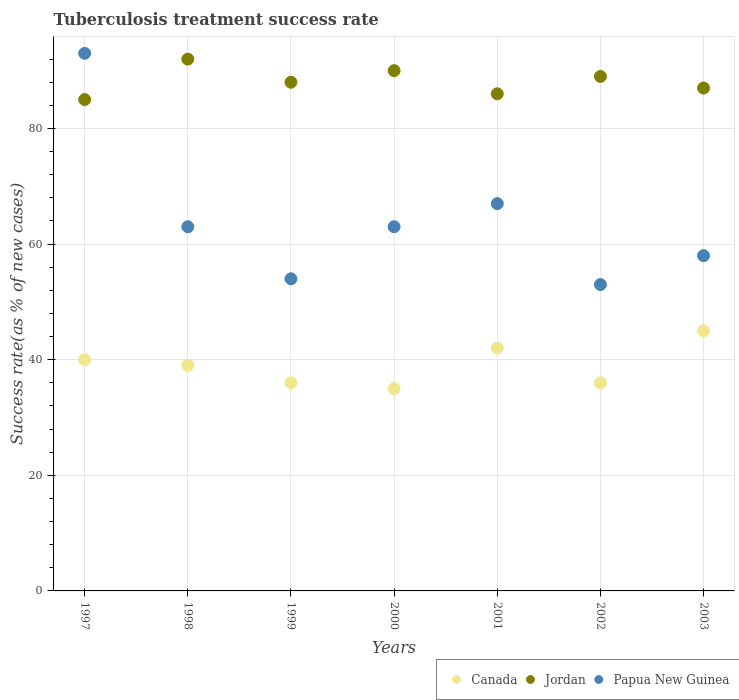How many different coloured dotlines are there?
Offer a very short reply. 3. Across all years, what is the maximum tuberculosis treatment success rate in Canada?
Keep it short and to the point. 45. Across all years, what is the minimum tuberculosis treatment success rate in Jordan?
Offer a terse response. 85. In which year was the tuberculosis treatment success rate in Canada minimum?
Keep it short and to the point. 2000. What is the total tuberculosis treatment success rate in Jordan in the graph?
Keep it short and to the point. 617. What is the difference between the tuberculosis treatment success rate in Papua New Guinea in 1997 and that in 1998?
Give a very brief answer. 30. What is the difference between the tuberculosis treatment success rate in Canada in 1997 and the tuberculosis treatment success rate in Papua New Guinea in 1999?
Keep it short and to the point. -14. What is the average tuberculosis treatment success rate in Canada per year?
Ensure brevity in your answer.  39. In the year 2000, what is the difference between the tuberculosis treatment success rate in Jordan and tuberculosis treatment success rate in Papua New Guinea?
Offer a terse response. 27. What is the ratio of the tuberculosis treatment success rate in Jordan in 1997 to that in 2003?
Your response must be concise. 0.98. Is the tuberculosis treatment success rate in Canada in 1997 less than that in 2000?
Provide a short and direct response. No. Is the difference between the tuberculosis treatment success rate in Jordan in 1998 and 1999 greater than the difference between the tuberculosis treatment success rate in Papua New Guinea in 1998 and 1999?
Offer a terse response. No. In how many years, is the tuberculosis treatment success rate in Papua New Guinea greater than the average tuberculosis treatment success rate in Papua New Guinea taken over all years?
Your answer should be compact. 2. Is the sum of the tuberculosis treatment success rate in Jordan in 1997 and 2002 greater than the maximum tuberculosis treatment success rate in Papua New Guinea across all years?
Your answer should be compact. Yes. Is it the case that in every year, the sum of the tuberculosis treatment success rate in Jordan and tuberculosis treatment success rate in Papua New Guinea  is greater than the tuberculosis treatment success rate in Canada?
Offer a very short reply. Yes. Does the tuberculosis treatment success rate in Canada monotonically increase over the years?
Keep it short and to the point. No. Is the tuberculosis treatment success rate in Canada strictly greater than the tuberculosis treatment success rate in Jordan over the years?
Your answer should be very brief. No. Is the tuberculosis treatment success rate in Jordan strictly less than the tuberculosis treatment success rate in Canada over the years?
Give a very brief answer. No. How many years are there in the graph?
Your answer should be very brief. 7. Does the graph contain grids?
Your response must be concise. Yes. How many legend labels are there?
Provide a succinct answer. 3. What is the title of the graph?
Your response must be concise. Tuberculosis treatment success rate. Does "Small states" appear as one of the legend labels in the graph?
Provide a succinct answer. No. What is the label or title of the X-axis?
Keep it short and to the point. Years. What is the label or title of the Y-axis?
Ensure brevity in your answer.  Success rate(as % of new cases). What is the Success rate(as % of new cases) in Canada in 1997?
Your answer should be very brief. 40. What is the Success rate(as % of new cases) in Jordan in 1997?
Make the answer very short. 85. What is the Success rate(as % of new cases) of Papua New Guinea in 1997?
Provide a short and direct response. 93. What is the Success rate(as % of new cases) in Canada in 1998?
Keep it short and to the point. 39. What is the Success rate(as % of new cases) of Jordan in 1998?
Offer a very short reply. 92. What is the Success rate(as % of new cases) in Canada in 1999?
Offer a very short reply. 36. What is the Success rate(as % of new cases) of Jordan in 1999?
Provide a succinct answer. 88. What is the Success rate(as % of new cases) in Papua New Guinea in 2000?
Offer a terse response. 63. What is the Success rate(as % of new cases) in Canada in 2002?
Your response must be concise. 36. What is the Success rate(as % of new cases) in Jordan in 2002?
Make the answer very short. 89. What is the Success rate(as % of new cases) of Canada in 2003?
Provide a short and direct response. 45. What is the Success rate(as % of new cases) of Jordan in 2003?
Provide a short and direct response. 87. Across all years, what is the maximum Success rate(as % of new cases) of Jordan?
Your answer should be compact. 92. Across all years, what is the maximum Success rate(as % of new cases) of Papua New Guinea?
Provide a succinct answer. 93. Across all years, what is the minimum Success rate(as % of new cases) in Canada?
Ensure brevity in your answer.  35. What is the total Success rate(as % of new cases) in Canada in the graph?
Ensure brevity in your answer.  273. What is the total Success rate(as % of new cases) in Jordan in the graph?
Your answer should be very brief. 617. What is the total Success rate(as % of new cases) in Papua New Guinea in the graph?
Your answer should be very brief. 451. What is the difference between the Success rate(as % of new cases) of Canada in 1997 and that in 1998?
Give a very brief answer. 1. What is the difference between the Success rate(as % of new cases) of Canada in 1997 and that in 2000?
Your answer should be compact. 5. What is the difference between the Success rate(as % of new cases) in Jordan in 1997 and that in 2000?
Your response must be concise. -5. What is the difference between the Success rate(as % of new cases) of Jordan in 1997 and that in 2001?
Your response must be concise. -1. What is the difference between the Success rate(as % of new cases) of Canada in 1997 and that in 2002?
Ensure brevity in your answer.  4. What is the difference between the Success rate(as % of new cases) of Canada in 1997 and that in 2003?
Your answer should be compact. -5. What is the difference between the Success rate(as % of new cases) in Jordan in 1997 and that in 2003?
Your answer should be very brief. -2. What is the difference between the Success rate(as % of new cases) of Papua New Guinea in 1997 and that in 2003?
Give a very brief answer. 35. What is the difference between the Success rate(as % of new cases) of Canada in 1998 and that in 1999?
Your answer should be compact. 3. What is the difference between the Success rate(as % of new cases) in Jordan in 1998 and that in 2000?
Your response must be concise. 2. What is the difference between the Success rate(as % of new cases) in Jordan in 1998 and that in 2001?
Your answer should be very brief. 6. What is the difference between the Success rate(as % of new cases) of Canada in 1998 and that in 2002?
Offer a terse response. 3. What is the difference between the Success rate(as % of new cases) of Papua New Guinea in 1998 and that in 2002?
Offer a terse response. 10. What is the difference between the Success rate(as % of new cases) of Canada in 1999 and that in 2000?
Provide a succinct answer. 1. What is the difference between the Success rate(as % of new cases) in Papua New Guinea in 1999 and that in 2000?
Your answer should be compact. -9. What is the difference between the Success rate(as % of new cases) of Canada in 1999 and that in 2002?
Provide a succinct answer. 0. What is the difference between the Success rate(as % of new cases) of Jordan in 1999 and that in 2003?
Provide a succinct answer. 1. What is the difference between the Success rate(as % of new cases) in Papua New Guinea in 1999 and that in 2003?
Give a very brief answer. -4. What is the difference between the Success rate(as % of new cases) in Canada in 2000 and that in 2001?
Provide a succinct answer. -7. What is the difference between the Success rate(as % of new cases) of Papua New Guinea in 2000 and that in 2001?
Keep it short and to the point. -4. What is the difference between the Success rate(as % of new cases) in Canada in 2000 and that in 2002?
Ensure brevity in your answer.  -1. What is the difference between the Success rate(as % of new cases) of Jordan in 2000 and that in 2002?
Your answer should be compact. 1. What is the difference between the Success rate(as % of new cases) in Papua New Guinea in 2000 and that in 2002?
Ensure brevity in your answer.  10. What is the difference between the Success rate(as % of new cases) in Canada in 2000 and that in 2003?
Your answer should be compact. -10. What is the difference between the Success rate(as % of new cases) in Jordan in 2000 and that in 2003?
Ensure brevity in your answer.  3. What is the difference between the Success rate(as % of new cases) in Papua New Guinea in 2001 and that in 2002?
Your answer should be very brief. 14. What is the difference between the Success rate(as % of new cases) of Jordan in 2002 and that in 2003?
Offer a terse response. 2. What is the difference between the Success rate(as % of new cases) of Papua New Guinea in 2002 and that in 2003?
Your response must be concise. -5. What is the difference between the Success rate(as % of new cases) of Canada in 1997 and the Success rate(as % of new cases) of Jordan in 1998?
Ensure brevity in your answer.  -52. What is the difference between the Success rate(as % of new cases) in Canada in 1997 and the Success rate(as % of new cases) in Papua New Guinea in 1998?
Offer a very short reply. -23. What is the difference between the Success rate(as % of new cases) of Canada in 1997 and the Success rate(as % of new cases) of Jordan in 1999?
Your response must be concise. -48. What is the difference between the Success rate(as % of new cases) of Canada in 1997 and the Success rate(as % of new cases) of Jordan in 2001?
Give a very brief answer. -46. What is the difference between the Success rate(as % of new cases) of Jordan in 1997 and the Success rate(as % of new cases) of Papua New Guinea in 2001?
Make the answer very short. 18. What is the difference between the Success rate(as % of new cases) in Canada in 1997 and the Success rate(as % of new cases) in Jordan in 2002?
Ensure brevity in your answer.  -49. What is the difference between the Success rate(as % of new cases) in Canada in 1997 and the Success rate(as % of new cases) in Papua New Guinea in 2002?
Your response must be concise. -13. What is the difference between the Success rate(as % of new cases) of Canada in 1997 and the Success rate(as % of new cases) of Jordan in 2003?
Ensure brevity in your answer.  -47. What is the difference between the Success rate(as % of new cases) of Canada in 1997 and the Success rate(as % of new cases) of Papua New Guinea in 2003?
Offer a terse response. -18. What is the difference between the Success rate(as % of new cases) in Canada in 1998 and the Success rate(as % of new cases) in Jordan in 1999?
Give a very brief answer. -49. What is the difference between the Success rate(as % of new cases) in Canada in 1998 and the Success rate(as % of new cases) in Papua New Guinea in 1999?
Your response must be concise. -15. What is the difference between the Success rate(as % of new cases) of Jordan in 1998 and the Success rate(as % of new cases) of Papua New Guinea in 1999?
Offer a very short reply. 38. What is the difference between the Success rate(as % of new cases) of Canada in 1998 and the Success rate(as % of new cases) of Jordan in 2000?
Your response must be concise. -51. What is the difference between the Success rate(as % of new cases) of Canada in 1998 and the Success rate(as % of new cases) of Papua New Guinea in 2000?
Keep it short and to the point. -24. What is the difference between the Success rate(as % of new cases) of Canada in 1998 and the Success rate(as % of new cases) of Jordan in 2001?
Your answer should be very brief. -47. What is the difference between the Success rate(as % of new cases) in Canada in 1998 and the Success rate(as % of new cases) in Papua New Guinea in 2001?
Your answer should be very brief. -28. What is the difference between the Success rate(as % of new cases) in Jordan in 1998 and the Success rate(as % of new cases) in Papua New Guinea in 2001?
Ensure brevity in your answer.  25. What is the difference between the Success rate(as % of new cases) of Canada in 1998 and the Success rate(as % of new cases) of Jordan in 2003?
Provide a short and direct response. -48. What is the difference between the Success rate(as % of new cases) of Canada in 1999 and the Success rate(as % of new cases) of Jordan in 2000?
Provide a short and direct response. -54. What is the difference between the Success rate(as % of new cases) of Jordan in 1999 and the Success rate(as % of new cases) of Papua New Guinea in 2000?
Offer a very short reply. 25. What is the difference between the Success rate(as % of new cases) in Canada in 1999 and the Success rate(as % of new cases) in Papua New Guinea in 2001?
Keep it short and to the point. -31. What is the difference between the Success rate(as % of new cases) of Jordan in 1999 and the Success rate(as % of new cases) of Papua New Guinea in 2001?
Your response must be concise. 21. What is the difference between the Success rate(as % of new cases) of Canada in 1999 and the Success rate(as % of new cases) of Jordan in 2002?
Offer a very short reply. -53. What is the difference between the Success rate(as % of new cases) in Canada in 1999 and the Success rate(as % of new cases) in Papua New Guinea in 2002?
Keep it short and to the point. -17. What is the difference between the Success rate(as % of new cases) in Canada in 1999 and the Success rate(as % of new cases) in Jordan in 2003?
Your answer should be very brief. -51. What is the difference between the Success rate(as % of new cases) of Canada in 2000 and the Success rate(as % of new cases) of Jordan in 2001?
Your response must be concise. -51. What is the difference between the Success rate(as % of new cases) in Canada in 2000 and the Success rate(as % of new cases) in Papua New Guinea in 2001?
Give a very brief answer. -32. What is the difference between the Success rate(as % of new cases) of Canada in 2000 and the Success rate(as % of new cases) of Jordan in 2002?
Keep it short and to the point. -54. What is the difference between the Success rate(as % of new cases) in Jordan in 2000 and the Success rate(as % of new cases) in Papua New Guinea in 2002?
Keep it short and to the point. 37. What is the difference between the Success rate(as % of new cases) in Canada in 2000 and the Success rate(as % of new cases) in Jordan in 2003?
Your response must be concise. -52. What is the difference between the Success rate(as % of new cases) of Canada in 2001 and the Success rate(as % of new cases) of Jordan in 2002?
Provide a short and direct response. -47. What is the difference between the Success rate(as % of new cases) of Canada in 2001 and the Success rate(as % of new cases) of Jordan in 2003?
Your response must be concise. -45. What is the difference between the Success rate(as % of new cases) of Jordan in 2001 and the Success rate(as % of new cases) of Papua New Guinea in 2003?
Your answer should be compact. 28. What is the difference between the Success rate(as % of new cases) of Canada in 2002 and the Success rate(as % of new cases) of Jordan in 2003?
Ensure brevity in your answer.  -51. What is the difference between the Success rate(as % of new cases) of Canada in 2002 and the Success rate(as % of new cases) of Papua New Guinea in 2003?
Give a very brief answer. -22. What is the difference between the Success rate(as % of new cases) of Jordan in 2002 and the Success rate(as % of new cases) of Papua New Guinea in 2003?
Your answer should be very brief. 31. What is the average Success rate(as % of new cases) of Canada per year?
Give a very brief answer. 39. What is the average Success rate(as % of new cases) of Jordan per year?
Keep it short and to the point. 88.14. What is the average Success rate(as % of new cases) in Papua New Guinea per year?
Your answer should be very brief. 64.43. In the year 1997, what is the difference between the Success rate(as % of new cases) of Canada and Success rate(as % of new cases) of Jordan?
Offer a very short reply. -45. In the year 1997, what is the difference between the Success rate(as % of new cases) in Canada and Success rate(as % of new cases) in Papua New Guinea?
Your answer should be compact. -53. In the year 1998, what is the difference between the Success rate(as % of new cases) in Canada and Success rate(as % of new cases) in Jordan?
Keep it short and to the point. -53. In the year 1998, what is the difference between the Success rate(as % of new cases) in Canada and Success rate(as % of new cases) in Papua New Guinea?
Offer a terse response. -24. In the year 1999, what is the difference between the Success rate(as % of new cases) in Canada and Success rate(as % of new cases) in Jordan?
Provide a succinct answer. -52. In the year 2000, what is the difference between the Success rate(as % of new cases) in Canada and Success rate(as % of new cases) in Jordan?
Your answer should be compact. -55. In the year 2001, what is the difference between the Success rate(as % of new cases) of Canada and Success rate(as % of new cases) of Jordan?
Offer a very short reply. -44. In the year 2001, what is the difference between the Success rate(as % of new cases) of Canada and Success rate(as % of new cases) of Papua New Guinea?
Provide a short and direct response. -25. In the year 2001, what is the difference between the Success rate(as % of new cases) of Jordan and Success rate(as % of new cases) of Papua New Guinea?
Make the answer very short. 19. In the year 2002, what is the difference between the Success rate(as % of new cases) of Canada and Success rate(as % of new cases) of Jordan?
Provide a succinct answer. -53. In the year 2002, what is the difference between the Success rate(as % of new cases) in Jordan and Success rate(as % of new cases) in Papua New Guinea?
Offer a terse response. 36. In the year 2003, what is the difference between the Success rate(as % of new cases) in Canada and Success rate(as % of new cases) in Jordan?
Your response must be concise. -42. In the year 2003, what is the difference between the Success rate(as % of new cases) in Canada and Success rate(as % of new cases) in Papua New Guinea?
Your answer should be very brief. -13. What is the ratio of the Success rate(as % of new cases) in Canada in 1997 to that in 1998?
Offer a very short reply. 1.03. What is the ratio of the Success rate(as % of new cases) in Jordan in 1997 to that in 1998?
Your answer should be compact. 0.92. What is the ratio of the Success rate(as % of new cases) in Papua New Guinea in 1997 to that in 1998?
Your answer should be very brief. 1.48. What is the ratio of the Success rate(as % of new cases) of Jordan in 1997 to that in 1999?
Your answer should be compact. 0.97. What is the ratio of the Success rate(as % of new cases) of Papua New Guinea in 1997 to that in 1999?
Your answer should be compact. 1.72. What is the ratio of the Success rate(as % of new cases) of Jordan in 1997 to that in 2000?
Provide a short and direct response. 0.94. What is the ratio of the Success rate(as % of new cases) of Papua New Guinea in 1997 to that in 2000?
Ensure brevity in your answer.  1.48. What is the ratio of the Success rate(as % of new cases) in Canada in 1997 to that in 2001?
Give a very brief answer. 0.95. What is the ratio of the Success rate(as % of new cases) of Jordan in 1997 to that in 2001?
Make the answer very short. 0.99. What is the ratio of the Success rate(as % of new cases) of Papua New Guinea in 1997 to that in 2001?
Provide a short and direct response. 1.39. What is the ratio of the Success rate(as % of new cases) in Canada in 1997 to that in 2002?
Ensure brevity in your answer.  1.11. What is the ratio of the Success rate(as % of new cases) of Jordan in 1997 to that in 2002?
Your response must be concise. 0.96. What is the ratio of the Success rate(as % of new cases) in Papua New Guinea in 1997 to that in 2002?
Offer a very short reply. 1.75. What is the ratio of the Success rate(as % of new cases) of Canada in 1997 to that in 2003?
Keep it short and to the point. 0.89. What is the ratio of the Success rate(as % of new cases) of Papua New Guinea in 1997 to that in 2003?
Offer a terse response. 1.6. What is the ratio of the Success rate(as % of new cases) of Jordan in 1998 to that in 1999?
Ensure brevity in your answer.  1.05. What is the ratio of the Success rate(as % of new cases) of Canada in 1998 to that in 2000?
Provide a succinct answer. 1.11. What is the ratio of the Success rate(as % of new cases) of Jordan in 1998 to that in 2000?
Make the answer very short. 1.02. What is the ratio of the Success rate(as % of new cases) in Papua New Guinea in 1998 to that in 2000?
Provide a short and direct response. 1. What is the ratio of the Success rate(as % of new cases) in Jordan in 1998 to that in 2001?
Provide a succinct answer. 1.07. What is the ratio of the Success rate(as % of new cases) in Papua New Guinea in 1998 to that in 2001?
Give a very brief answer. 0.94. What is the ratio of the Success rate(as % of new cases) of Canada in 1998 to that in 2002?
Offer a terse response. 1.08. What is the ratio of the Success rate(as % of new cases) in Jordan in 1998 to that in 2002?
Keep it short and to the point. 1.03. What is the ratio of the Success rate(as % of new cases) of Papua New Guinea in 1998 to that in 2002?
Your response must be concise. 1.19. What is the ratio of the Success rate(as % of new cases) of Canada in 1998 to that in 2003?
Ensure brevity in your answer.  0.87. What is the ratio of the Success rate(as % of new cases) in Jordan in 1998 to that in 2003?
Ensure brevity in your answer.  1.06. What is the ratio of the Success rate(as % of new cases) of Papua New Guinea in 1998 to that in 2003?
Provide a short and direct response. 1.09. What is the ratio of the Success rate(as % of new cases) of Canada in 1999 to that in 2000?
Provide a succinct answer. 1.03. What is the ratio of the Success rate(as % of new cases) in Jordan in 1999 to that in 2000?
Make the answer very short. 0.98. What is the ratio of the Success rate(as % of new cases) of Papua New Guinea in 1999 to that in 2000?
Your answer should be very brief. 0.86. What is the ratio of the Success rate(as % of new cases) in Jordan in 1999 to that in 2001?
Make the answer very short. 1.02. What is the ratio of the Success rate(as % of new cases) of Papua New Guinea in 1999 to that in 2001?
Your response must be concise. 0.81. What is the ratio of the Success rate(as % of new cases) in Canada in 1999 to that in 2002?
Ensure brevity in your answer.  1. What is the ratio of the Success rate(as % of new cases) in Papua New Guinea in 1999 to that in 2002?
Provide a succinct answer. 1.02. What is the ratio of the Success rate(as % of new cases) in Canada in 1999 to that in 2003?
Provide a short and direct response. 0.8. What is the ratio of the Success rate(as % of new cases) of Jordan in 1999 to that in 2003?
Provide a succinct answer. 1.01. What is the ratio of the Success rate(as % of new cases) in Papua New Guinea in 1999 to that in 2003?
Provide a short and direct response. 0.93. What is the ratio of the Success rate(as % of new cases) of Jordan in 2000 to that in 2001?
Offer a terse response. 1.05. What is the ratio of the Success rate(as % of new cases) of Papua New Guinea in 2000 to that in 2001?
Provide a succinct answer. 0.94. What is the ratio of the Success rate(as % of new cases) in Canada in 2000 to that in 2002?
Your answer should be compact. 0.97. What is the ratio of the Success rate(as % of new cases) of Jordan in 2000 to that in 2002?
Make the answer very short. 1.01. What is the ratio of the Success rate(as % of new cases) of Papua New Guinea in 2000 to that in 2002?
Your answer should be very brief. 1.19. What is the ratio of the Success rate(as % of new cases) of Jordan in 2000 to that in 2003?
Offer a terse response. 1.03. What is the ratio of the Success rate(as % of new cases) in Papua New Guinea in 2000 to that in 2003?
Offer a very short reply. 1.09. What is the ratio of the Success rate(as % of new cases) in Jordan in 2001 to that in 2002?
Your answer should be very brief. 0.97. What is the ratio of the Success rate(as % of new cases) in Papua New Guinea in 2001 to that in 2002?
Your answer should be compact. 1.26. What is the ratio of the Success rate(as % of new cases) of Canada in 2001 to that in 2003?
Keep it short and to the point. 0.93. What is the ratio of the Success rate(as % of new cases) in Jordan in 2001 to that in 2003?
Your answer should be compact. 0.99. What is the ratio of the Success rate(as % of new cases) in Papua New Guinea in 2001 to that in 2003?
Give a very brief answer. 1.16. What is the ratio of the Success rate(as % of new cases) of Canada in 2002 to that in 2003?
Your response must be concise. 0.8. What is the ratio of the Success rate(as % of new cases) of Papua New Guinea in 2002 to that in 2003?
Your response must be concise. 0.91. What is the difference between the highest and the second highest Success rate(as % of new cases) of Canada?
Make the answer very short. 3. What is the difference between the highest and the second highest Success rate(as % of new cases) of Jordan?
Your answer should be very brief. 2. What is the difference between the highest and the lowest Success rate(as % of new cases) in Canada?
Your response must be concise. 10. 